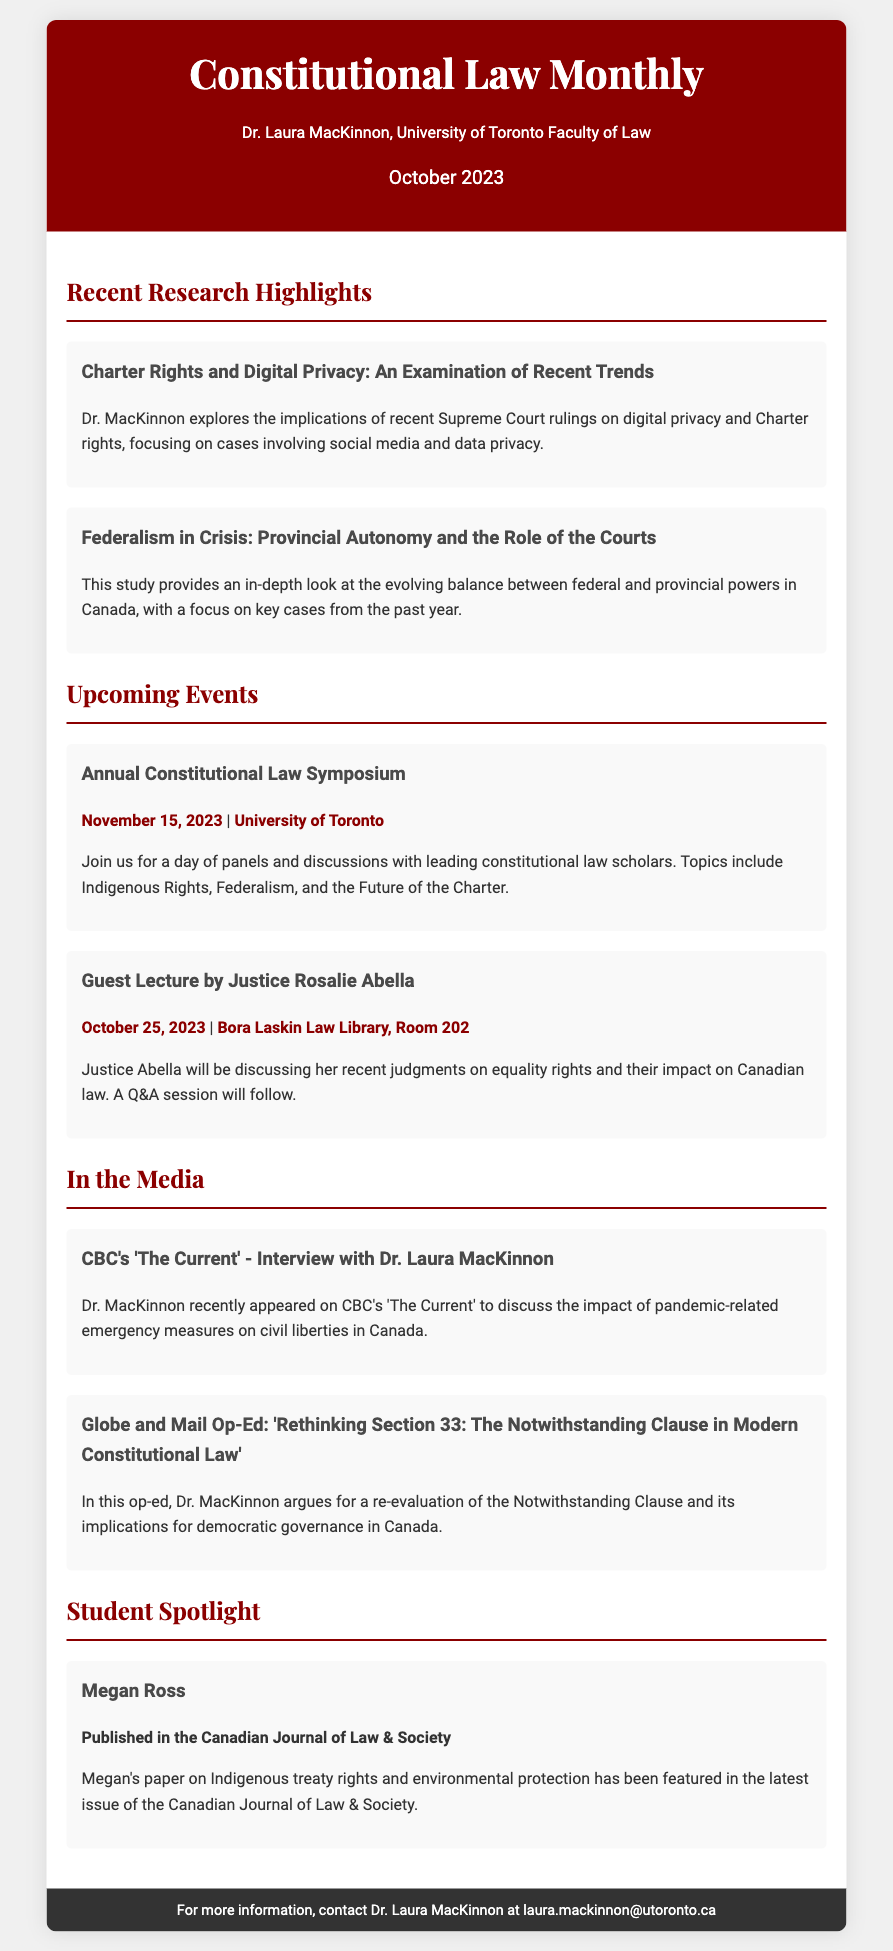What is the title of the newsletter? The title is prominently displayed at the top of the document as "Constitutional Law Monthly."
Answer: Constitutional Law Monthly Who is the author of the newsletter? The author is mentioned right below the title, indicating they are a law professor.
Answer: Dr. Laura MacKinnon What is the date of the newsletter? The date is specified in the header of the document.
Answer: October 2023 What is the topic of the first article in the Recent Research Highlights? The first article's title provides insight into its subject matter regarding digital privacy.
Answer: Charter Rights and Digital Privacy: An Examination of Recent Trends When is the Annual Constitutional Law Symposium scheduled? The date of the symposium is included in the event section.
Answer: November 15, 2023 Where will Justice Rosalie Abella's guest lecture take place? The location is provided in the details of the event.
Answer: Bora Laskin Law Library, Room 202 Who was featured as a student spotlight? The student spotlight section names a prominent student for recognition.
Answer: Megan Ross What is the focus of Megan Ross's published paper? The paper's topic is outlined in her description in the student spotlight section.
Answer: Indigenous treaty rights and environmental protection In which media outlet did Dr. MacKinnon give an interview? The media outlet is mentioned in the media section of the document.
Answer: CBC What overarching theme is covered in the op-ed by Dr. MacKinnon? The theme of the op-ed reflects on a significant aspect of constitutional law.
Answer: Rethinking Section 33: The Notwithstanding Clause in Modern Constitutional Law 